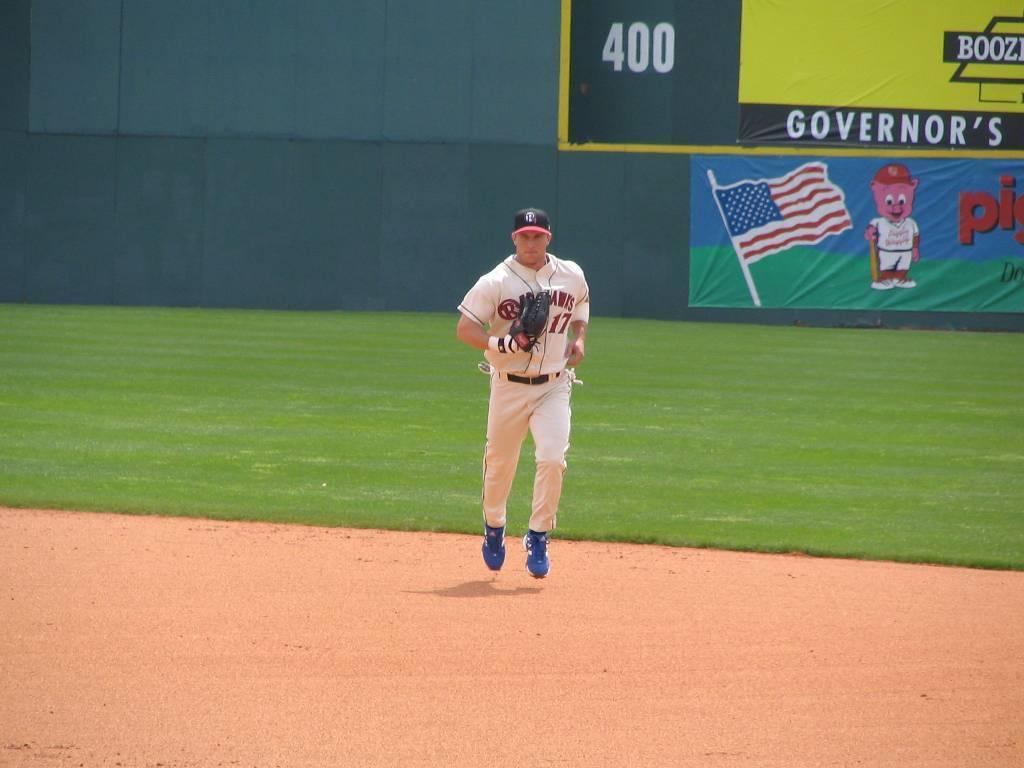Provide a one-sentence caption for the provided image. Professional base ball player coming in from the outfield which has banners for Piggly Wiggly and Governers on the back wall. 